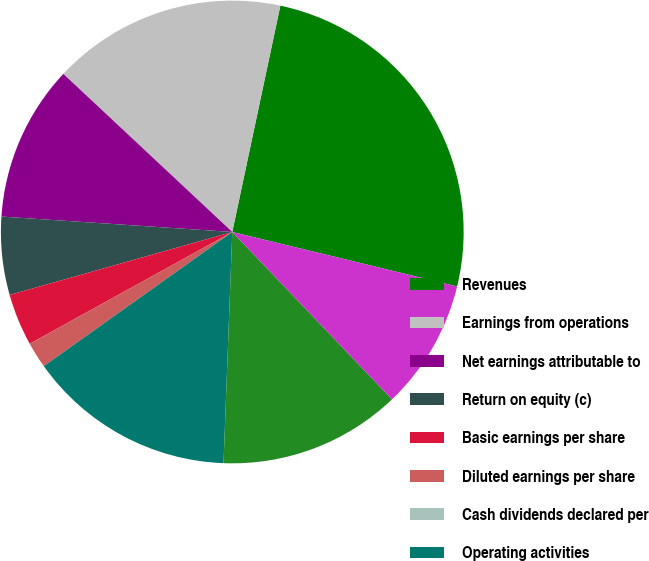Convert chart to OTSL. <chart><loc_0><loc_0><loc_500><loc_500><pie_chart><fcel>Revenues<fcel>Earnings from operations<fcel>Net earnings attributable to<fcel>Return on equity (c)<fcel>Basic earnings per share<fcel>Diluted earnings per share<fcel>Cash dividends declared per<fcel>Operating activities<fcel>Investing activities<fcel>Financing activities<nl><fcel>25.45%<fcel>16.36%<fcel>10.91%<fcel>5.45%<fcel>3.64%<fcel>1.82%<fcel>0.0%<fcel>14.55%<fcel>12.73%<fcel>9.09%<nl></chart> 